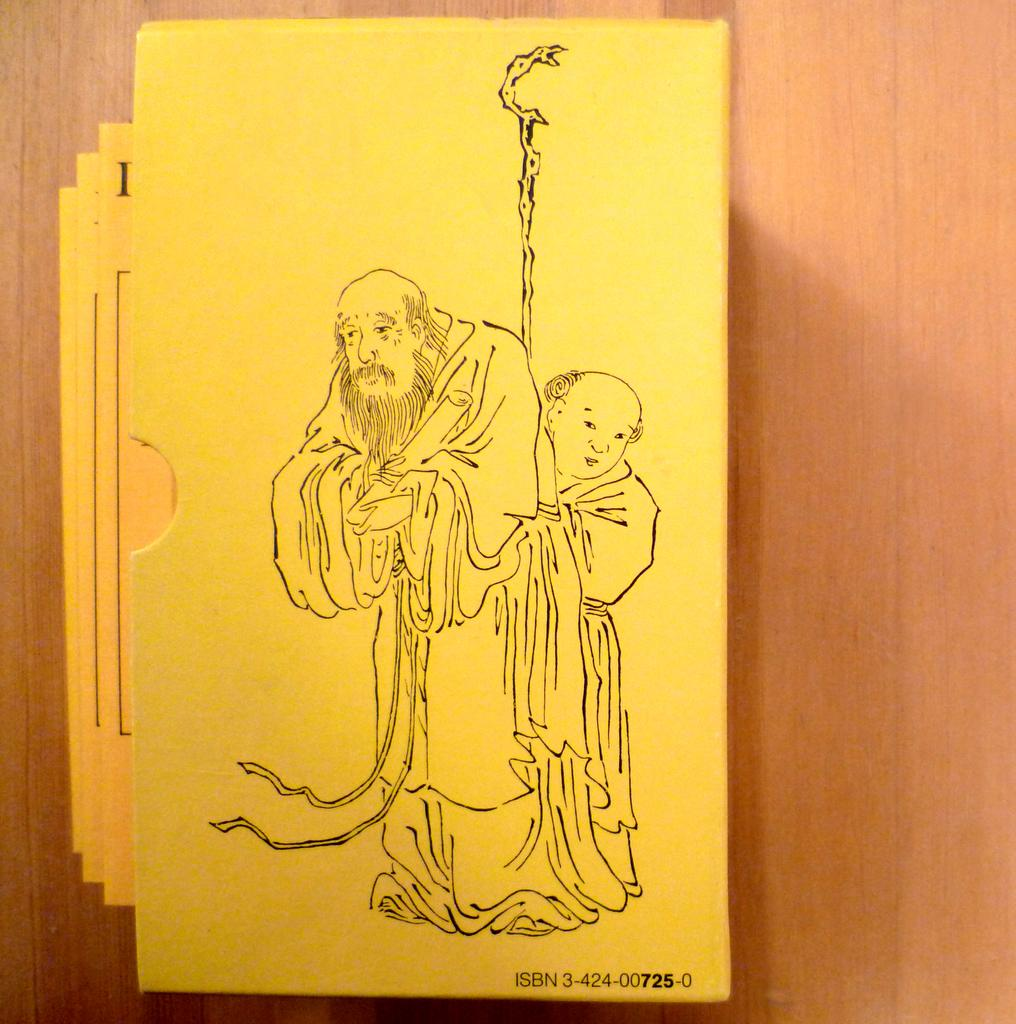What is the main subject of the image? The image resembles an envelope. What is inside the envelope? There are cards inside the envelope. Is there any design or image on the envelope? Yes, there is a picture on the envelope. What can be seen in the background of the image? There is a table in the background of the image. What type of underwear is visible in the image? There is no underwear present in the image. How much fuel is required to power the development shown in the image? There is no reference to fuel or development in the image; it features an envelope with cards and a picture. 